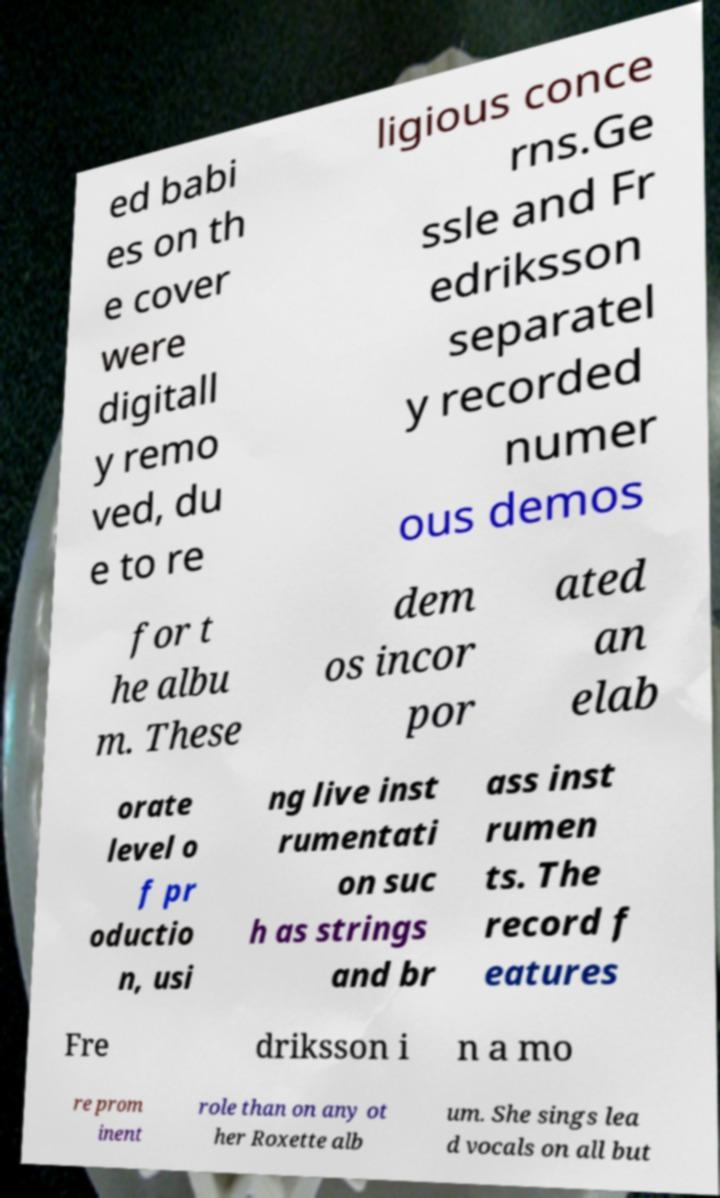Can you read and provide the text displayed in the image?This photo seems to have some interesting text. Can you extract and type it out for me? ed babi es on th e cover were digitall y remo ved, du e to re ligious conce rns.Ge ssle and Fr edriksson separatel y recorded numer ous demos for t he albu m. These dem os incor por ated an elab orate level o f pr oductio n, usi ng live inst rumentati on suc h as strings and br ass inst rumen ts. The record f eatures Fre driksson i n a mo re prom inent role than on any ot her Roxette alb um. She sings lea d vocals on all but 